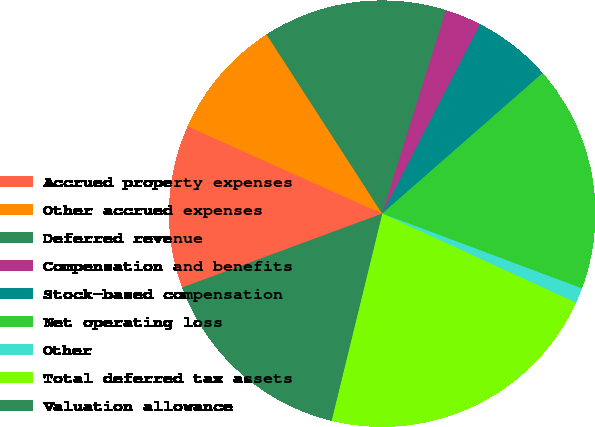<chart> <loc_0><loc_0><loc_500><loc_500><pie_chart><fcel>Accrued property expenses<fcel>Other accrued expenses<fcel>Deferred revenue<fcel>Compensation and benefits<fcel>Stock-based compensation<fcel>Net operating loss<fcel>Other<fcel>Total deferred tax assets<fcel>Valuation allowance<nl><fcel>12.35%<fcel>9.16%<fcel>13.95%<fcel>2.76%<fcel>5.96%<fcel>17.15%<fcel>1.16%<fcel>21.95%<fcel>15.55%<nl></chart> 